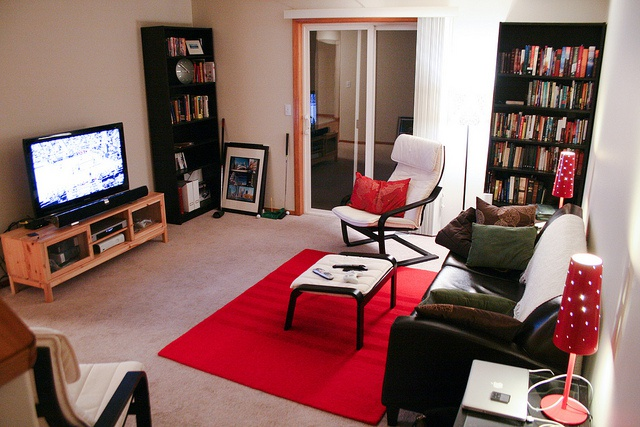Describe the objects in this image and their specific colors. I can see couch in gray, black, lightgray, and darkgray tones, book in gray, black, maroon, and brown tones, chair in gray, black, and darkgray tones, tv in gray, white, black, lightblue, and navy tones, and chair in gray, brown, lightgray, and darkgray tones in this image. 